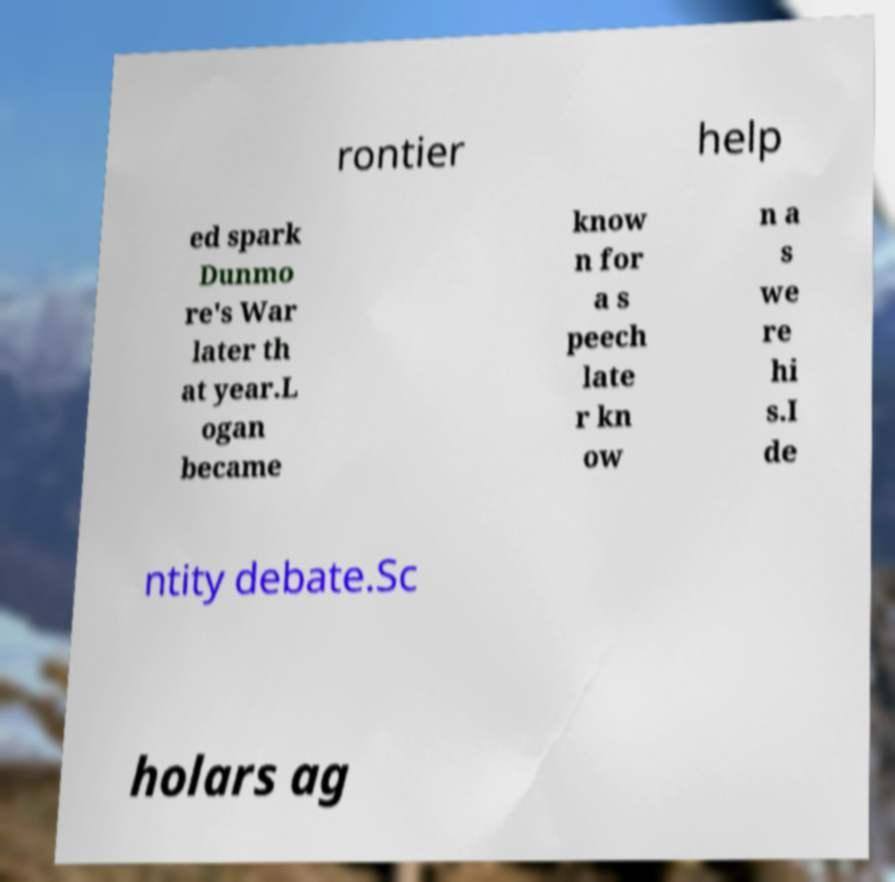Could you assist in decoding the text presented in this image and type it out clearly? rontier help ed spark Dunmo re's War later th at year.L ogan became know n for a s peech late r kn ow n a s we re hi s.I de ntity debate.Sc holars ag 